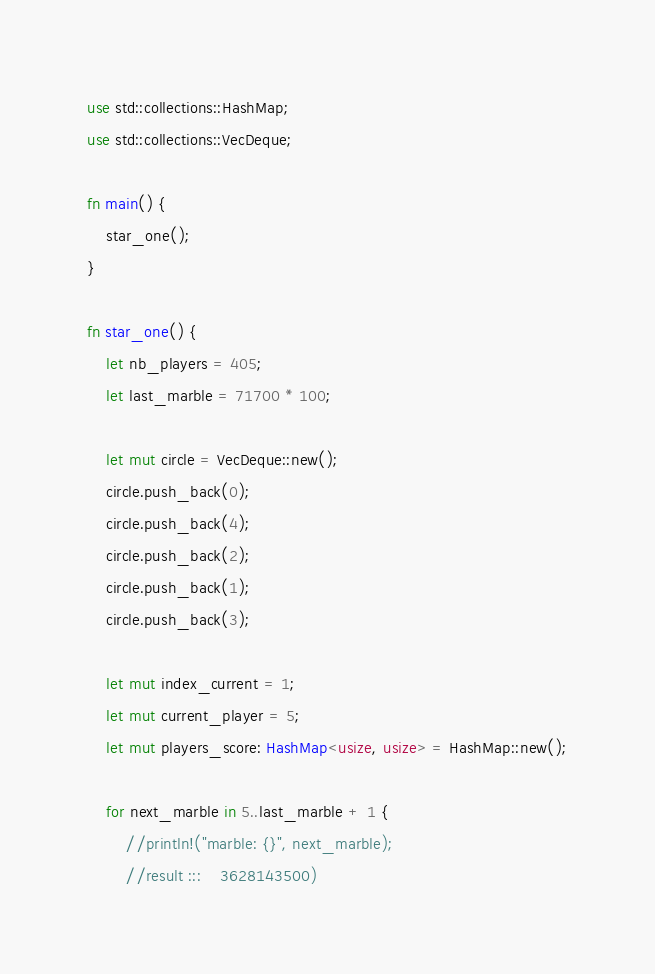Convert code to text. <code><loc_0><loc_0><loc_500><loc_500><_Rust_>use std::collections::HashMap;
use std::collections::VecDeque;

fn main() {
    star_one();
}

fn star_one() {
    let nb_players = 405;
    let last_marble = 71700 * 100;

    let mut circle = VecDeque::new();
    circle.push_back(0);
    circle.push_back(4);
    circle.push_back(2);
    circle.push_back(1);
    circle.push_back(3);

    let mut index_current = 1;
    let mut current_player = 5;
    let mut players_score: HashMap<usize, usize> = HashMap::new();

    for next_marble in 5..last_marble + 1 {
        //println!("marble: {}", next_marble);
        //result :::    3628143500)</code> 